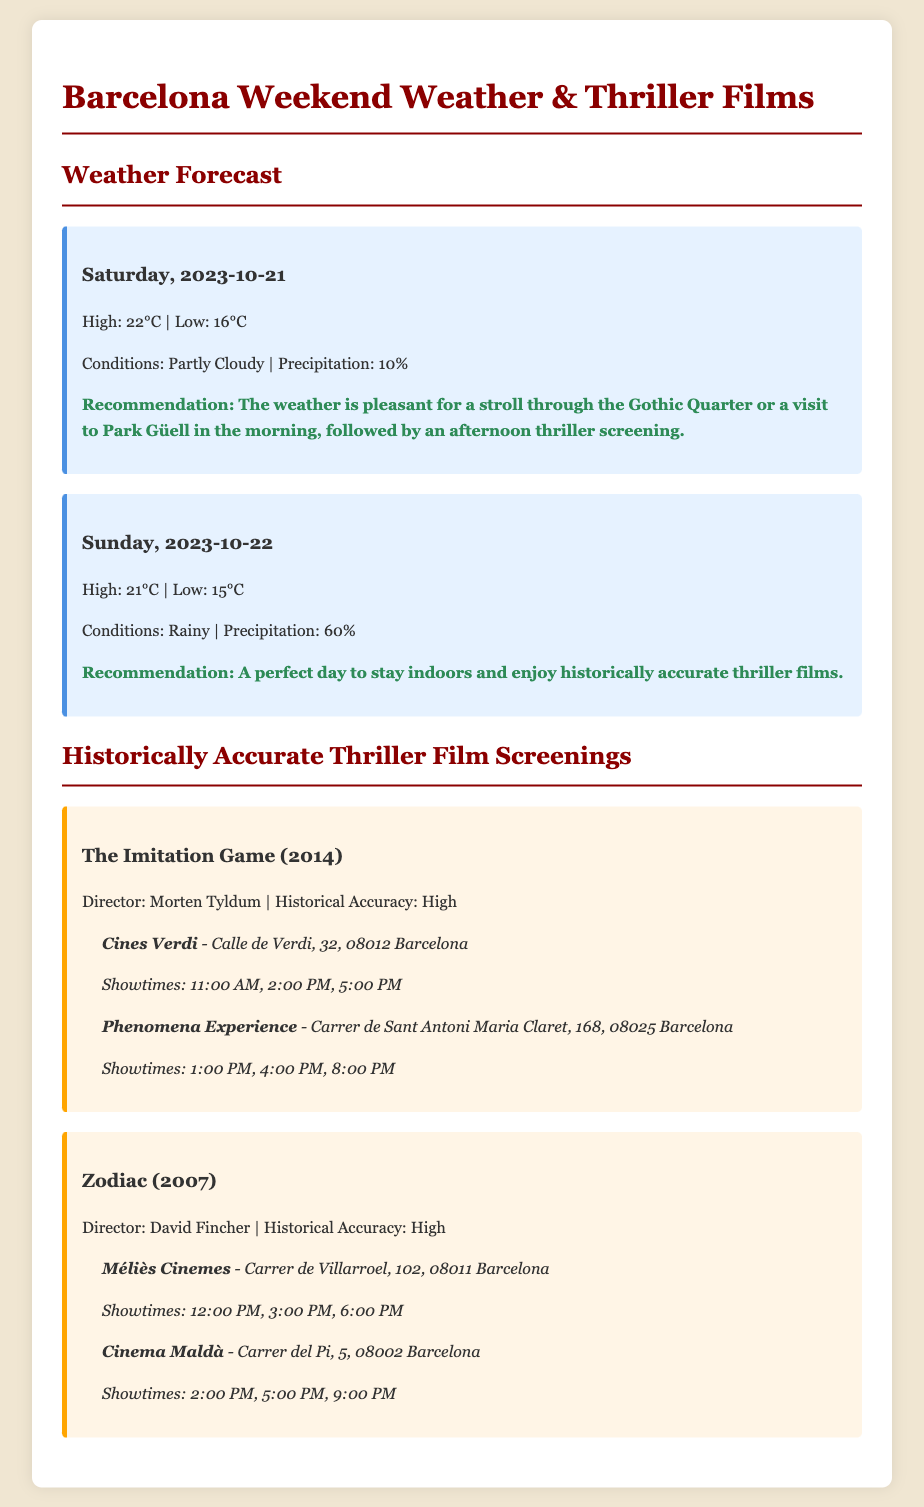What is the high temperature for Saturday? The high temperature for Saturday is mentioned in the weather forecast section, which states the high is 22°C.
Answer: 22°C What is the historical accuracy rating of "Zodiac"? The historical accuracy of "Zodiac" is noted in the film card, which states that its historical accuracy is high.
Answer: High How much precipitation is expected on Sunday? The precipitation amount for Sunday is listed in the weather forecast section, reporting a 60% chance of rain.
Answer: 60% What time does "The Imitation Game" start at Cines Verdi? The showtime for "The Imitation Game" at Cines Verdi can be found in the film card, which indicates that it starts at 11:00 AM.
Answer: 11:00 AM What is the recommendation for Saturday? The recommendation for Saturday is detailed in the weather forecast, suggesting a stroll in the Gothic Quarter, followed by an afternoon thriller screening.
Answer: A stroll through the Gothic Quarter or a visit to Park Güell in the morning, followed by an afternoon thriller screening 